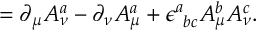<formula> <loc_0><loc_0><loc_500><loc_500>= \partial _ { \mu } A _ { \nu } ^ { a } - \partial _ { \nu } A _ { \mu } ^ { a } + \epsilon _ { \ b c } ^ { a } A _ { \mu } ^ { b } A _ { \nu } ^ { c } .</formula> 